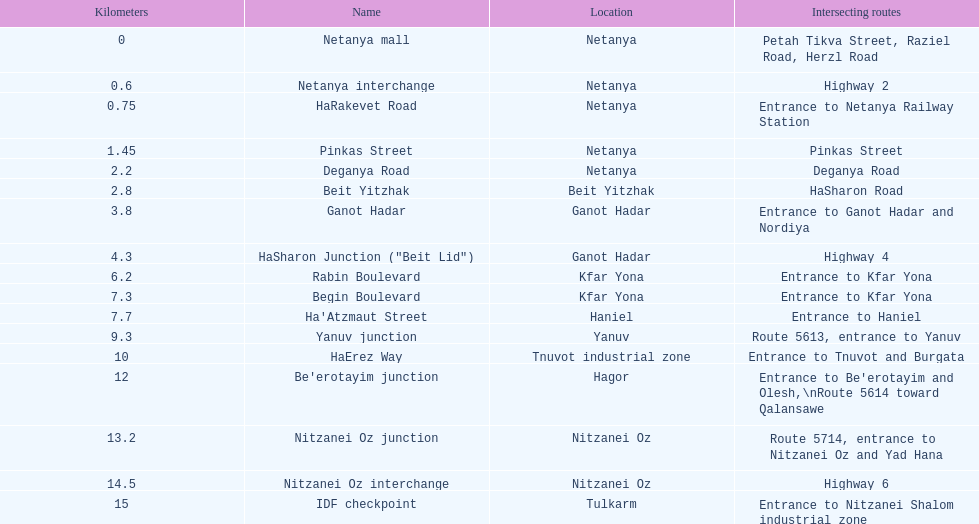How many portions are lo?cated in netanya 5. 